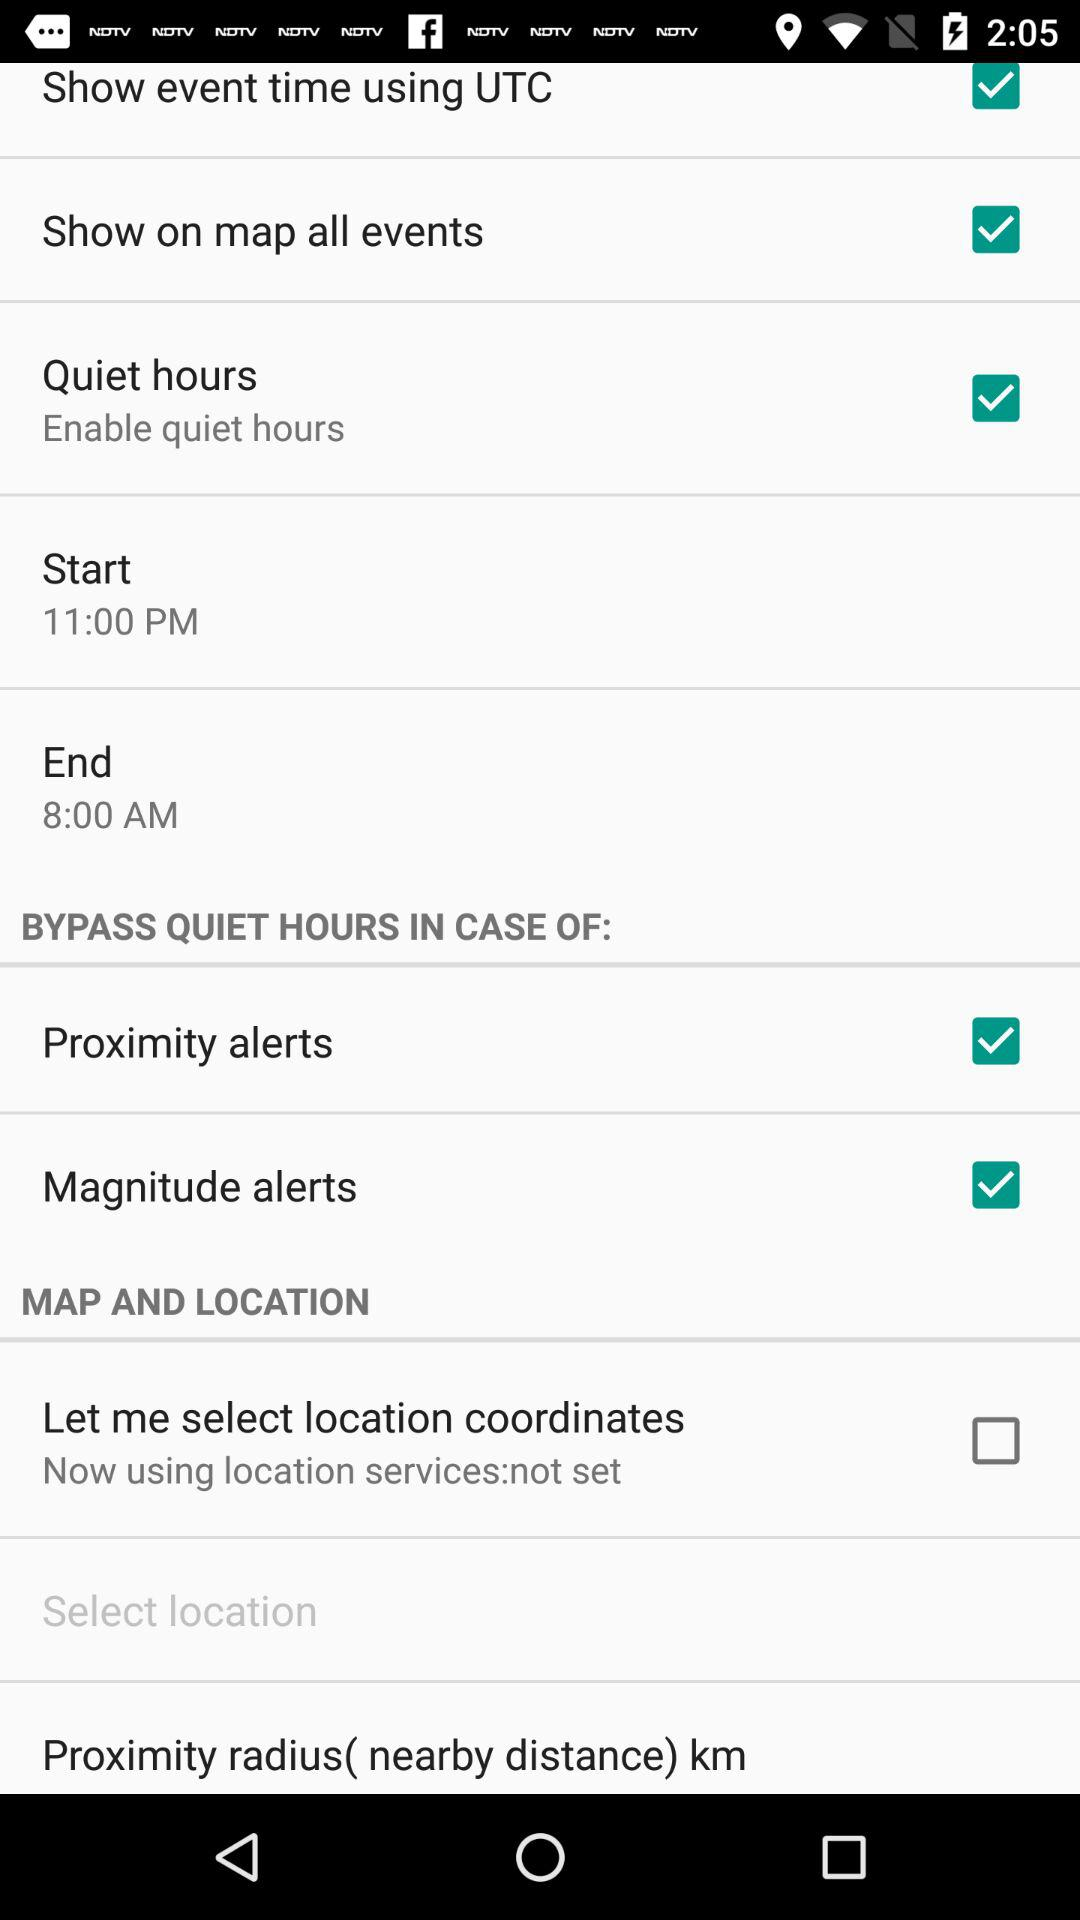What is the status of "Show on map all events"? The status is "on". 